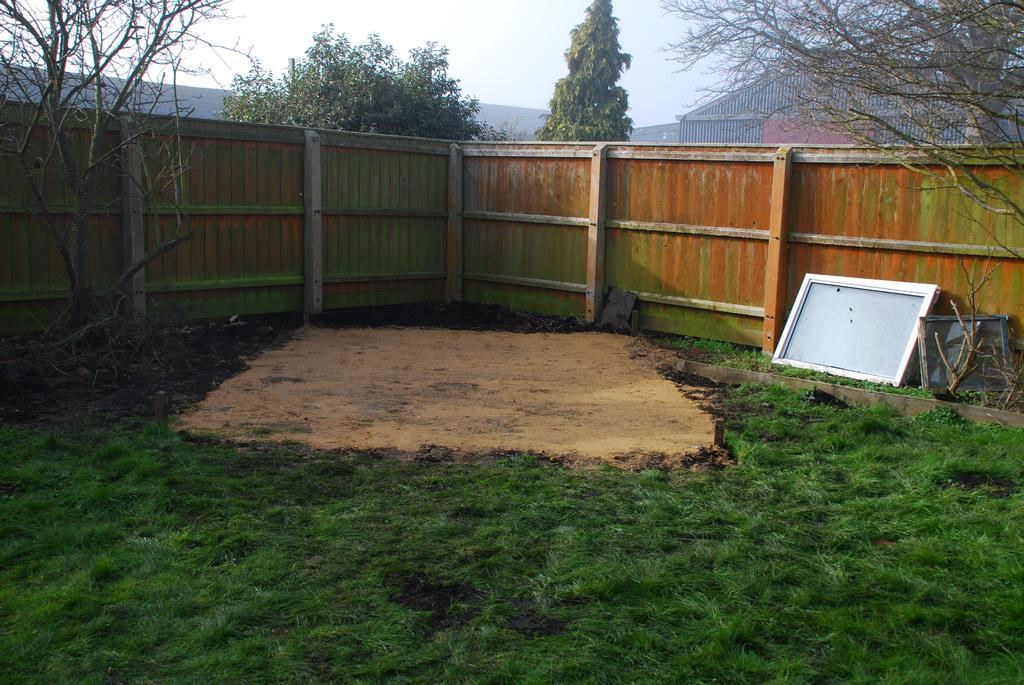What is located in the center of the image? There is a wall in the center of the image. What type of vegetation is at the bottom of the image? There is grass at the bottom of the image. What can be seen in the background of the image? There are trees in the background of the image. What type of structure is present in the image? There is a house in the image. What substance is the duck made of in the image? There is no duck present in the image, so it is not possible to determine what substance it might be made of. 